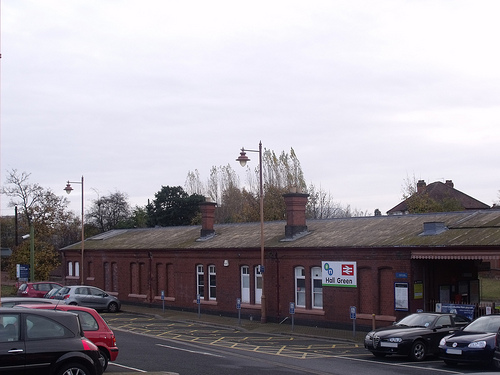<image>
Is the pole behind the building? No. The pole is not behind the building. From this viewpoint, the pole appears to be positioned elsewhere in the scene. 